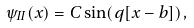Convert formula to latex. <formula><loc_0><loc_0><loc_500><loc_500>\psi _ { I I } ( x ) = C \sin ( q [ x - b ] ) \, ,</formula> 